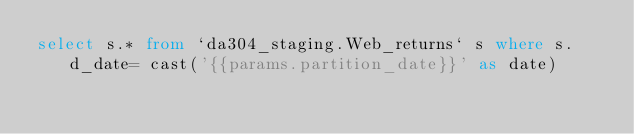<code> <loc_0><loc_0><loc_500><loc_500><_SQL_>select s.* from `da304_staging.Web_returns` s where s.d_date= cast('{{params.partition_date}}' as date)
</code> 